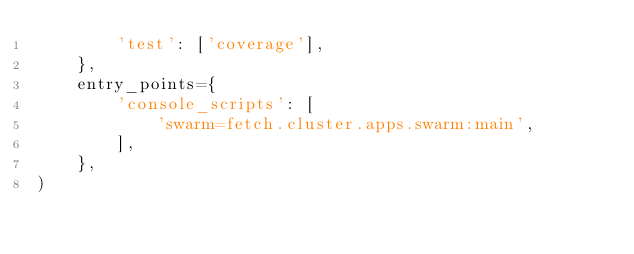<code> <loc_0><loc_0><loc_500><loc_500><_Python_>        'test': ['coverage'],
    },
    entry_points={
        'console_scripts': [
            'swarm=fetch.cluster.apps.swarm:main',
        ],
    },
)
</code> 